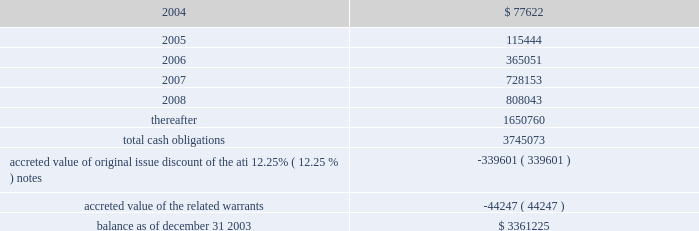American tower corporation and subsidiaries notes to consolidated financial statements 2014 ( continued ) maturities 2014as of december 31 , 2003 , aggregate principal payments of long-term debt , including capital leases , for the next five years and thereafter are estimated to be ( in thousands ) : year ending december 31 .
The holders of the company 2019s convertible notes have the right to require the company to repurchase their notes on specified dates prior to their maturity dates in 2009 and 2010 , but the company may pay the purchase price by issuing shares of class a common stock , subject to certain conditions .
Obligations with respect to the right of the holders to put the 6.25% ( 6.25 % ) notes and 5.0% ( 5.0 % ) notes have been included in the table above as if such notes mature on the date of their put rights in 2006 and 2007 , respectively .
( see note 19. ) 8 .
Derivative financial instruments under the terms of the credit facilities , the company is required to enter into interest rate protection agreements on at least 50% ( 50 % ) of its variable rate debt .
Under these agreements , the company is exposed to credit risk to the extent that a counterparty fails to meet the terms of a contract .
Such exposure is limited to the current value of the contract at the time the counterparty fails to perform .
The company believes its contracts as of december 31 , 2003 are with credit worthy institutions .
As of december 31 , 2003 , the company had three interest rate caps outstanding that include an aggregate notional amount of $ 500.0 million ( each at an interest rate of 5% ( 5 % ) ) and expire in 2004 .
As of december 31 , 2003 and 2002 , liabilities related to derivative financial instruments of $ 0.0 million and $ 15.5 million are reflected in other long-term liabilities in the accompanying consolidated balance sheet .
During the year ended december 31 , 2003 , the company recorded an unrealized loss of approximately $ 0.3 million ( net of a tax benefit of approximately $ 0.2 million ) in other comprehensive loss for the change in fair value of cash flow hedges and reclassified $ 5.9 million ( net of a tax benefit of approximately $ 3.2 million ) into results of operations .
During the year ended december 31 , 2002 , the company recorded an unrealized loss of approximately $ 9.1 million ( net of a tax benefit of approximately $ 4.9 million ) in other comprehensive loss for the change in fair value of cash flow hedges and reclassified $ 19.5 million ( net of a tax benefit of approximately $ 10.5 million ) into results of operations .
Hedge ineffectiveness resulted in a gain of approximately $ 1.0 million and a loss of approximately $ 2.2 million for the years ended december 31 , 2002 and 2001 , respectively , which are recorded in loss on investments and other expense in the accompanying consolidated statements of operations for those periods .
The company records the changes in fair value of its derivative instruments that are not accounted for as hedges in loss on investments and other expense .
The company does not anticipate reclassifying any derivative losses into its statement of operations within the next twelve months , as there are no amounts included in other comprehensive loss as of december 31 , 2003. .
During the year ended december 2003 what was the tax rate applicable to the recorded an unrealized loss? 
Computations: ((0.3 - 0.2) / 0.3)
Answer: 0.33333. 